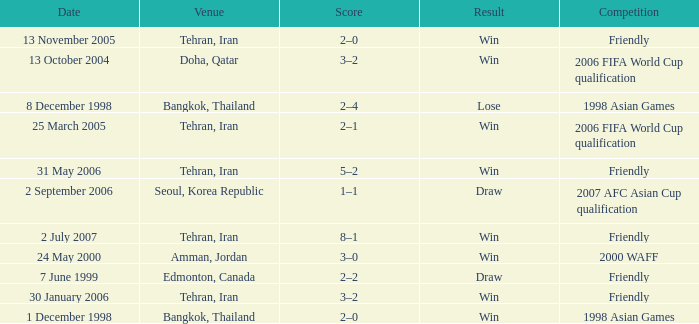What was the competition on 13 November 2005? Friendly. 